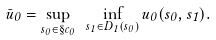<formula> <loc_0><loc_0><loc_500><loc_500>\bar { u } _ { 0 } = \sup _ { s _ { 0 } \in \S c _ { 0 } } \ \inf _ { s _ { 1 } \in D _ { 1 } ( s _ { 0 } ) } u _ { 0 } ( s _ { 0 } , s _ { 1 } ) .</formula> 